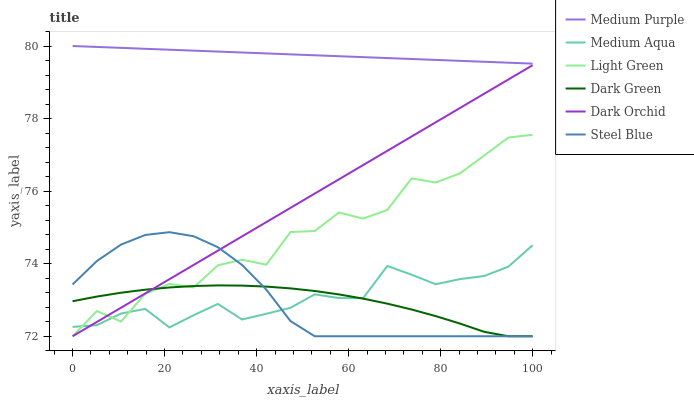Does Dark Green have the minimum area under the curve?
Answer yes or no. Yes. Does Medium Purple have the maximum area under the curve?
Answer yes or no. Yes. Does Dark Orchid have the minimum area under the curve?
Answer yes or no. No. Does Dark Orchid have the maximum area under the curve?
Answer yes or no. No. Is Dark Orchid the smoothest?
Answer yes or no. Yes. Is Light Green the roughest?
Answer yes or no. Yes. Is Medium Purple the smoothest?
Answer yes or no. No. Is Medium Purple the roughest?
Answer yes or no. No. Does Steel Blue have the lowest value?
Answer yes or no. Yes. Does Medium Purple have the lowest value?
Answer yes or no. No. Does Medium Purple have the highest value?
Answer yes or no. Yes. Does Dark Orchid have the highest value?
Answer yes or no. No. Is Medium Aqua less than Medium Purple?
Answer yes or no. Yes. Is Medium Purple greater than Light Green?
Answer yes or no. Yes. Does Dark Orchid intersect Dark Green?
Answer yes or no. Yes. Is Dark Orchid less than Dark Green?
Answer yes or no. No. Is Dark Orchid greater than Dark Green?
Answer yes or no. No. Does Medium Aqua intersect Medium Purple?
Answer yes or no. No. 